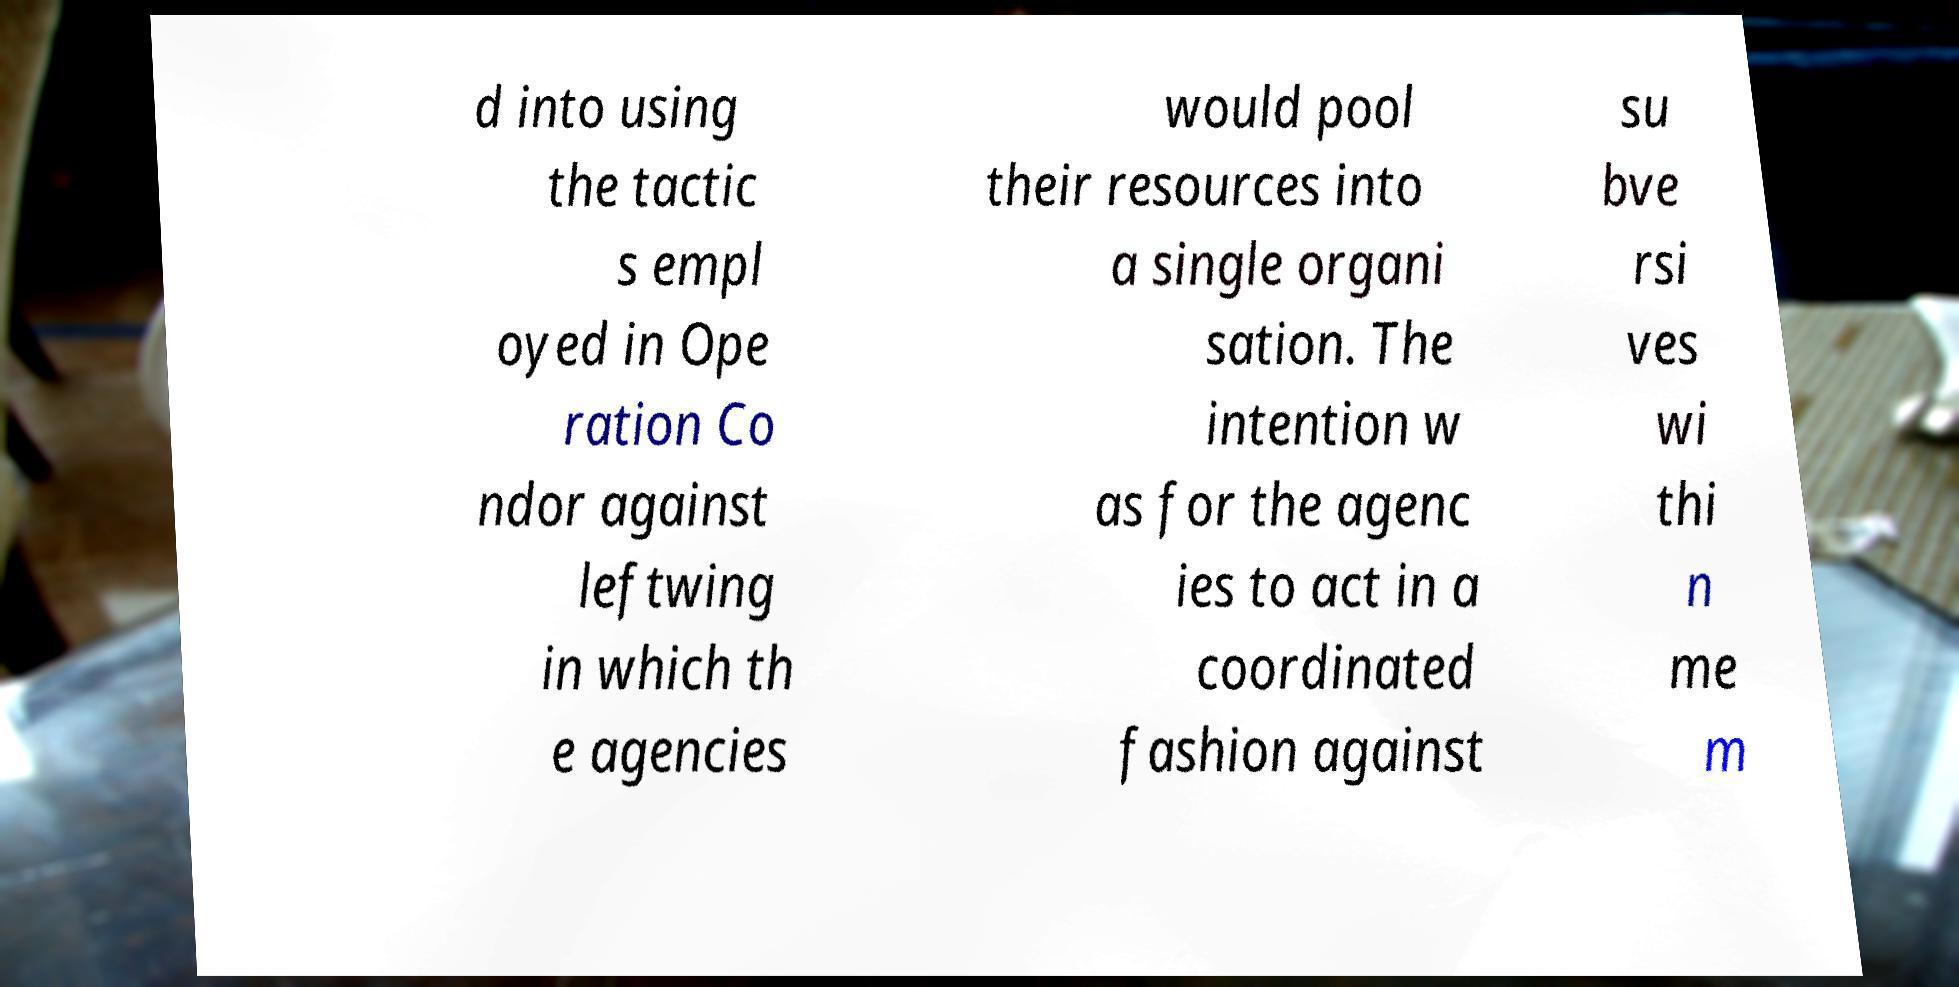I need the written content from this picture converted into text. Can you do that? d into using the tactic s empl oyed in Ope ration Co ndor against leftwing in which th e agencies would pool their resources into a single organi sation. The intention w as for the agenc ies to act in a coordinated fashion against su bve rsi ves wi thi n me m 